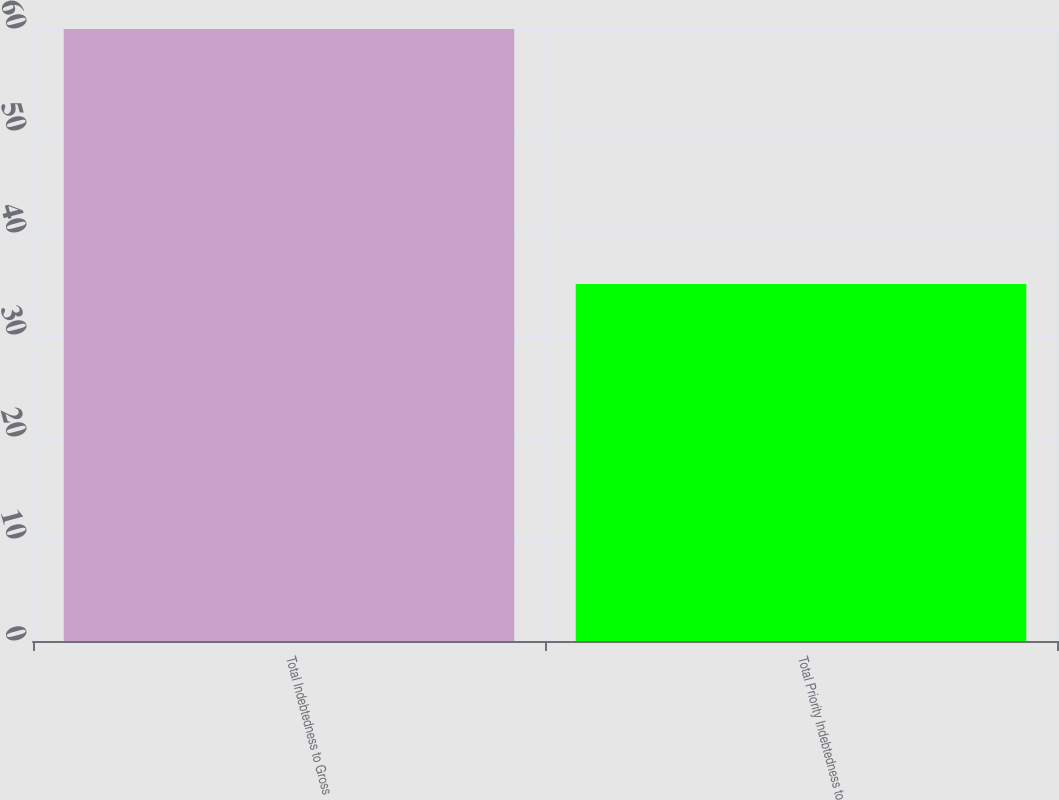<chart> <loc_0><loc_0><loc_500><loc_500><bar_chart><fcel>Total Indebtedness to Gross<fcel>Total Priority Indebtedness to<nl><fcel>60<fcel>35<nl></chart> 